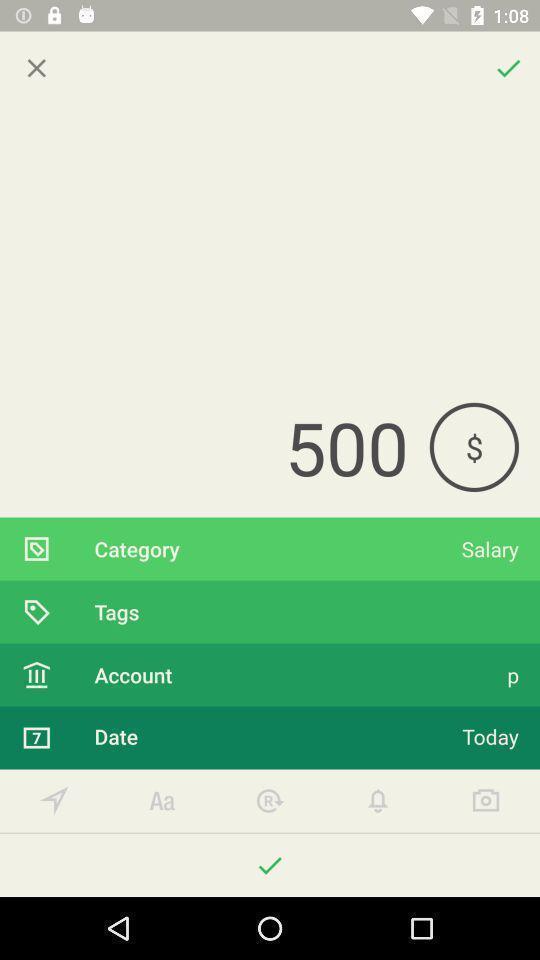What is the overall content of this screenshot? Screen displaying page of an banking application. 